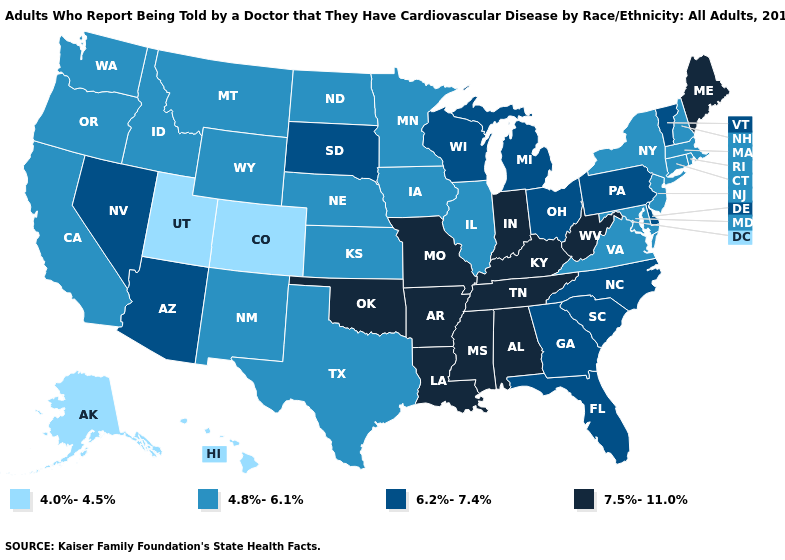How many symbols are there in the legend?
Be succinct. 4. Which states have the lowest value in the USA?
Keep it brief. Alaska, Colorado, Hawaii, Utah. Is the legend a continuous bar?
Concise answer only. No. What is the highest value in the USA?
Answer briefly. 7.5%-11.0%. How many symbols are there in the legend?
Concise answer only. 4. Does the map have missing data?
Write a very short answer. No. What is the value of Maryland?
Be succinct. 4.8%-6.1%. What is the lowest value in the South?
Give a very brief answer. 4.8%-6.1%. What is the value of Hawaii?
Short answer required. 4.0%-4.5%. Name the states that have a value in the range 6.2%-7.4%?
Answer briefly. Arizona, Delaware, Florida, Georgia, Michigan, Nevada, North Carolina, Ohio, Pennsylvania, South Carolina, South Dakota, Vermont, Wisconsin. Does Mississippi have a higher value than Arkansas?
Give a very brief answer. No. Does the map have missing data?
Write a very short answer. No. What is the value of Virginia?
Keep it brief. 4.8%-6.1%. Is the legend a continuous bar?
Give a very brief answer. No. Among the states that border Michigan , does Wisconsin have the lowest value?
Keep it brief. Yes. 